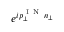<formula> <loc_0><loc_0><loc_500><loc_500>e ^ { i p _ { \perp } ^ { I N } n _ { \perp } }</formula> 